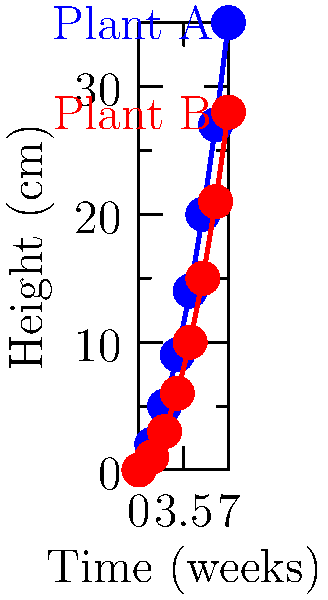In your therapeutic gardening program, you're analyzing the growth patterns of two plant species using time-lapse photos taken over 7 weeks. The graph shows the height progression of Plant A and Plant B. What is the difference in growth rate (cm/week) between Plant A and Plant B during this period? To solve this problem, we'll follow these steps:

1. Calculate the total growth for each plant:
   Plant A: $35 \text{ cm} - 0 \text{ cm} = 35 \text{ cm}$
   Plant B: $28 \text{ cm} - 0 \text{ cm} = 28 \text{ cm}$

2. Calculate the growth rate for each plant:
   Growth rate = Total growth / Time period
   
   Plant A: $35 \text{ cm} / 7 \text{ weeks} = 5 \text{ cm/week}$
   Plant B: $28 \text{ cm} / 7 \text{ weeks} = 4 \text{ cm/week}$

3. Calculate the difference in growth rates:
   Difference = Growth rate of Plant A - Growth rate of Plant B
   $5 \text{ cm/week} - 4 \text{ cm/week} = 1 \text{ cm/week}$

Therefore, the difference in growth rate between Plant A and Plant B is 1 cm/week.
Answer: 1 cm/week 